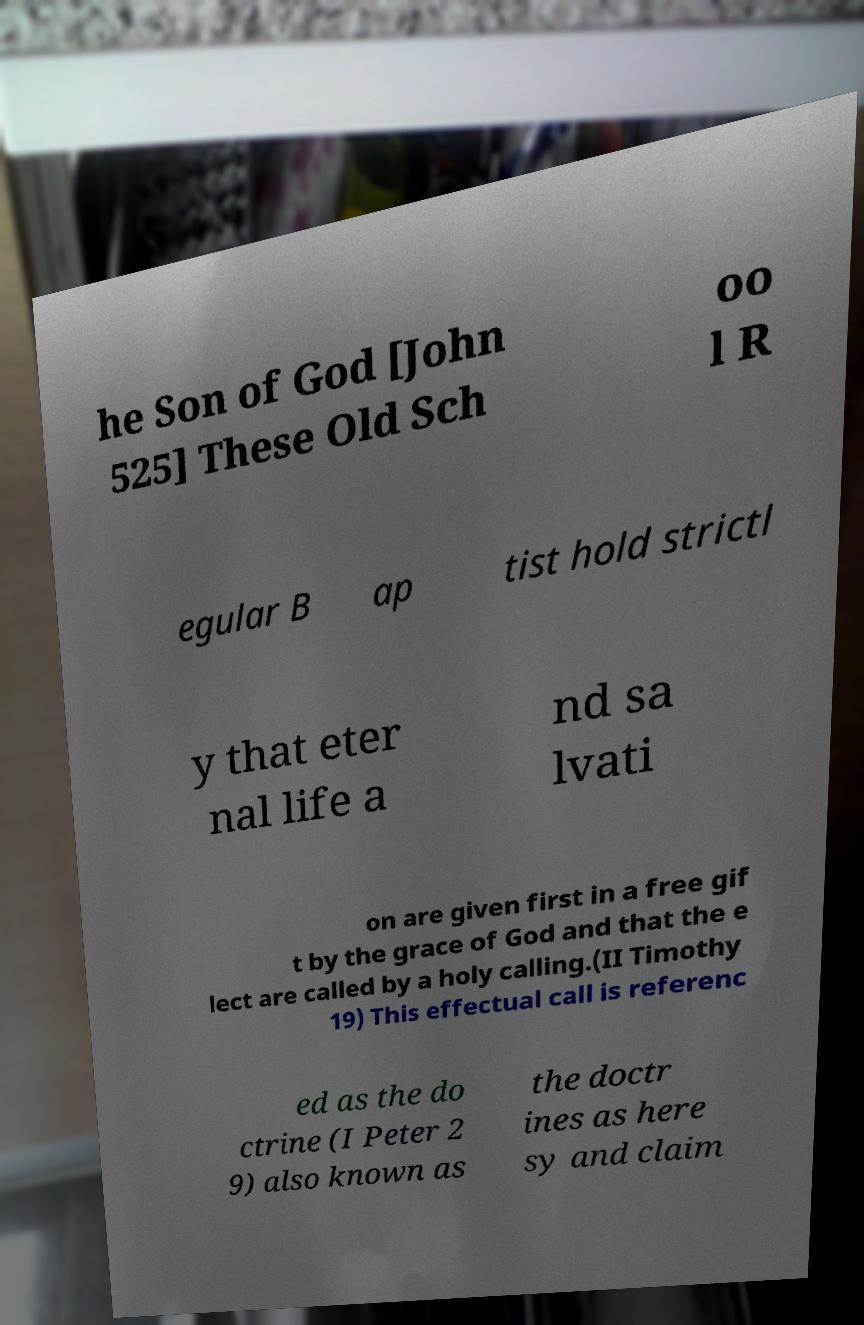Could you extract and type out the text from this image? he Son of God [John 525] These Old Sch oo l R egular B ap tist hold strictl y that eter nal life a nd sa lvati on are given first in a free gif t by the grace of God and that the e lect are called by a holy calling.(II Timothy 19) This effectual call is referenc ed as the do ctrine (I Peter 2 9) also known as the doctr ines as here sy and claim 